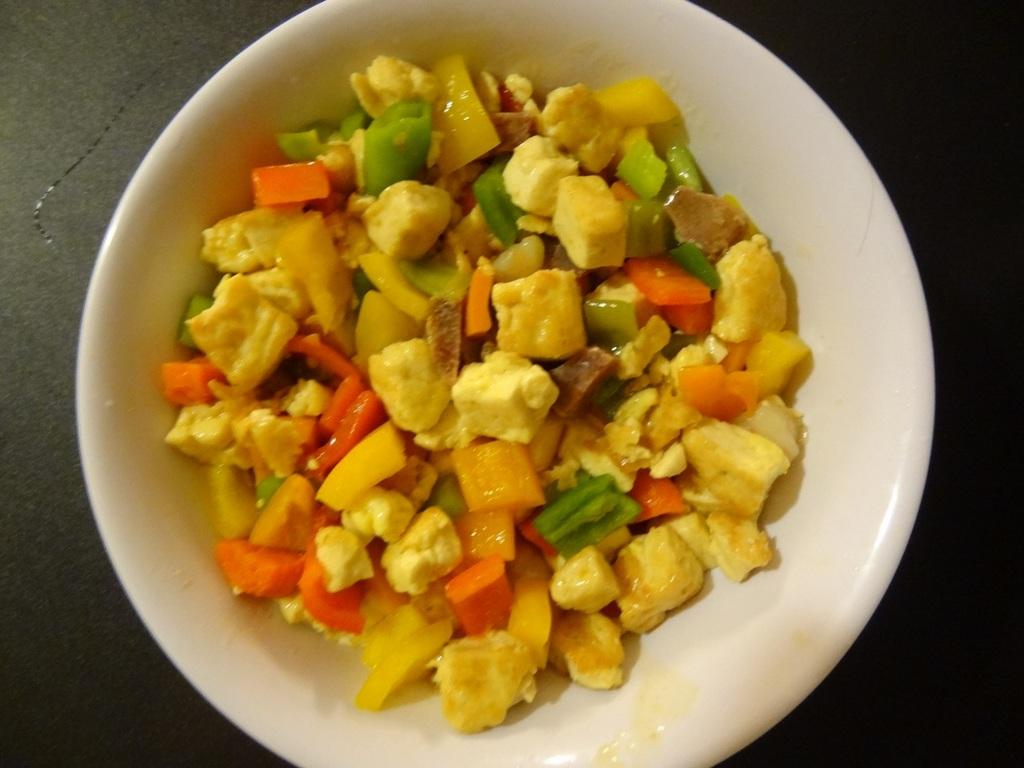What is present in the image? There is a bowl in the image. What is inside the bowl? The bowl contains a food item. What type of apparatus is used to cook the food item in the bowl? There is no apparatus or cooking process mentioned in the image, as it only shows a bowl with a food item. 